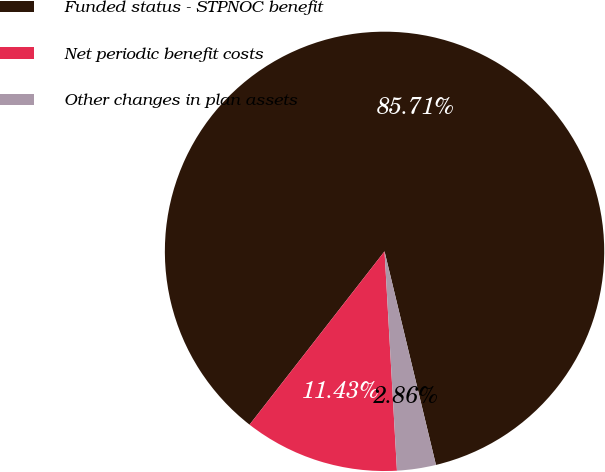Convert chart to OTSL. <chart><loc_0><loc_0><loc_500><loc_500><pie_chart><fcel>Funded status - STPNOC benefit<fcel>Net periodic benefit costs<fcel>Other changes in plan assets<nl><fcel>85.71%<fcel>11.43%<fcel>2.86%<nl></chart> 